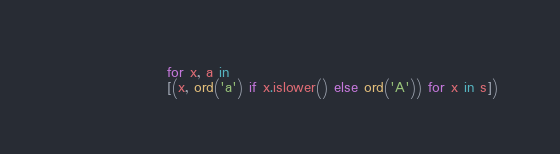<code> <loc_0><loc_0><loc_500><loc_500><_Python_>                   for x, a in
                   [(x, ord('a') if x.islower() else ord('A')) for x in s])
</code> 